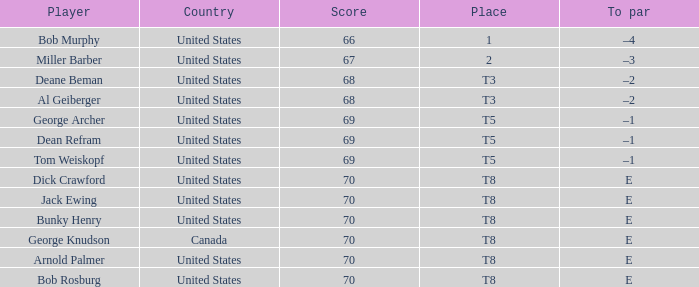When Bunky Henry placed t8, what was his To par? E. 